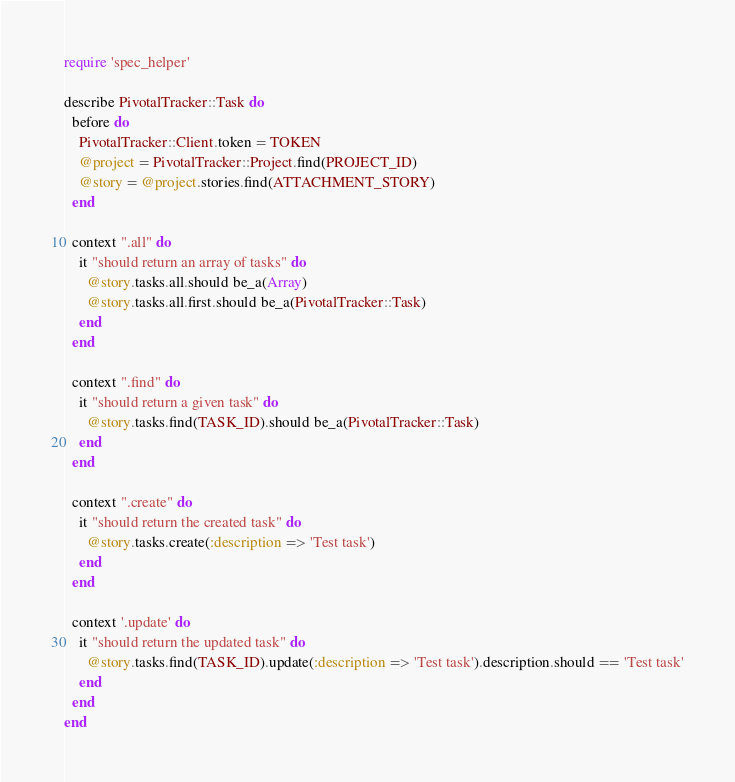<code> <loc_0><loc_0><loc_500><loc_500><_Ruby_>require 'spec_helper'

describe PivotalTracker::Task do
  before do
    PivotalTracker::Client.token = TOKEN
    @project = PivotalTracker::Project.find(PROJECT_ID)
    @story = @project.stories.find(ATTACHMENT_STORY)
  end

  context ".all" do
    it "should return an array of tasks" do
      @story.tasks.all.should be_a(Array)
      @story.tasks.all.first.should be_a(PivotalTracker::Task)
    end
  end

  context ".find" do
    it "should return a given task" do
      @story.tasks.find(TASK_ID).should be_a(PivotalTracker::Task)
    end
  end

  context ".create" do
    it "should return the created task" do
      @story.tasks.create(:description => 'Test task')
    end
  end

  context '.update' do
    it "should return the updated task" do
      @story.tasks.find(TASK_ID).update(:description => 'Test task').description.should == 'Test task'
    end
  end
end
</code> 